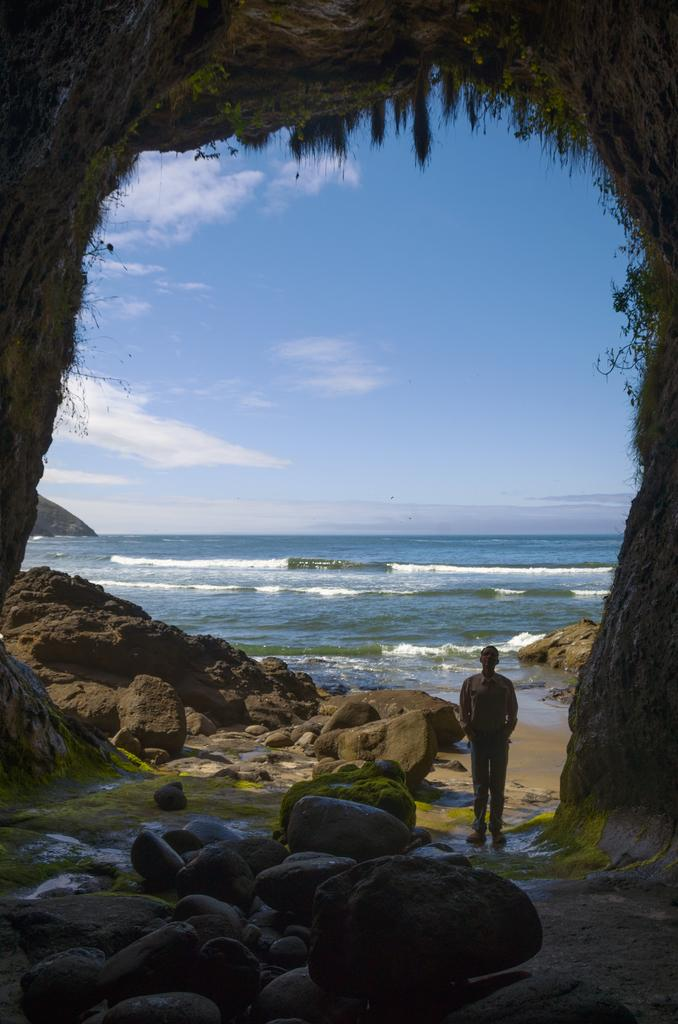Where is the person located in the image? There is a person standing in the right corner of the image. What is in front of the person? There are rocks in front of the person. What can be seen in the background of the image? There is water visible in the background of the image. What type of paste is being used to create shade in the image? There is no paste or shade present in the image; it features a person standing in front of rocks with water visible in the background. 